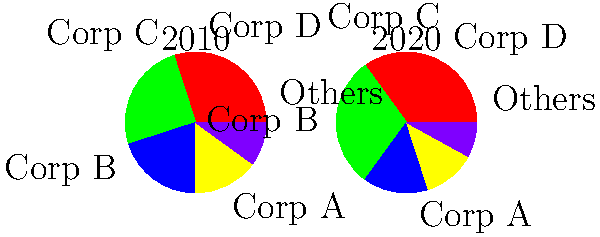Based on the market share pie charts of top food corporations in 2010 and 2020, which statement best describes the trend in market concentration? To analyze the trend in market concentration, we need to examine the changes in market share for the top corporations and the "Others" category:

1. Corp A: Increased from 30% to 35%
2. Corp B: Increased from 25% to 30%
3. Corp C: Decreased from 20% to 15%
4. Corp D: Decreased slightly from 15% to 12%
5. Others: Decreased from 10% to 8%

Key observations:
1. The two largest corporations (A and B) have increased their market share.
2. The smaller corporations (C and D) have lost market share.
3. The "Others" category, representing smaller players, has shrunk.

These changes indicate that the market is becoming more concentrated, with larger corporations gaining more control and smaller players losing ground. This trend aligns with the concept of market consolidation, where a few dominant players increase their market power over time.
Answer: Increased market concentration 